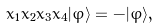Convert formula to latex. <formula><loc_0><loc_0><loc_500><loc_500>x _ { 1 } x _ { 2 } x _ { 3 } x _ { 4 } | \varphi \rangle = - | \varphi \rangle ,</formula> 